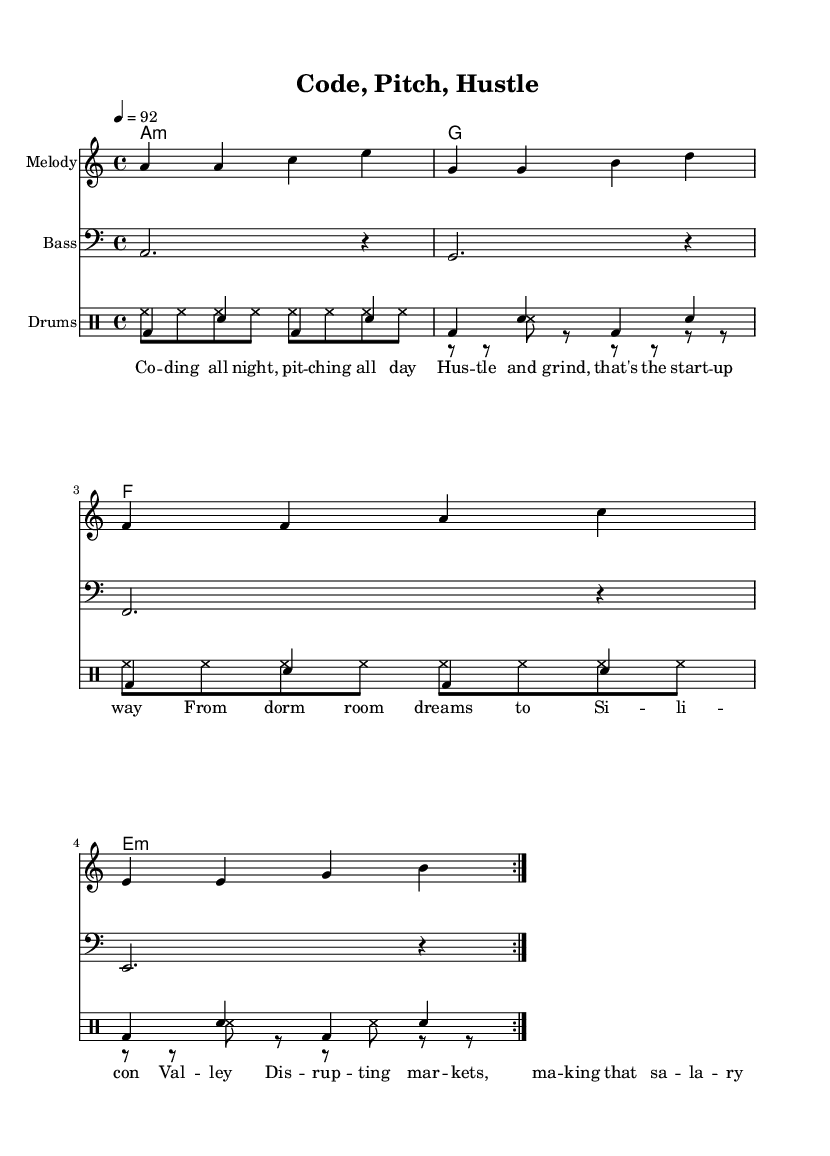What is the key signature of this music? The key signature is indicated at the beginning of the score, which shows one flat for A minor.
Answer: A minor What is the time signature of this music? The time signature appears in the first measure of the score. It is 4/4, indicating four beats per measure.
Answer: 4/4 What is the tempo of the piece? The tempo is marked at the beginning as 4 = 92, which means there are 92 quarter note beats per minute.
Answer: 92 How many measures does the melody repeat? The melody section is marked with a "volta" sign which signifies that it repeats twice. Counting the measures in the melody section confirms it.
Answer: 2 What type of instruments are used in this score? The score includes a melody staff, a bass staff, and a drum staff, indicating the use of melodic and rhythmic instruments.
Answer: Melody, Bass, Drums What mood or theme does the lyrics suggest? The lyrics focus on entrepreneurship themes like hustle, tech, and ambition, which reflect a modern rap narrative centered around startup culture.
Answer: Entrepreneurship Which musical elements contribute to the rap style in this piece? The beat pattern is highlighted through the drum part with a consistent kick and snare rhythm, along with a catchy melody that enhances the rap aesthetic.
Answer: Drum pattern, catchy melody 